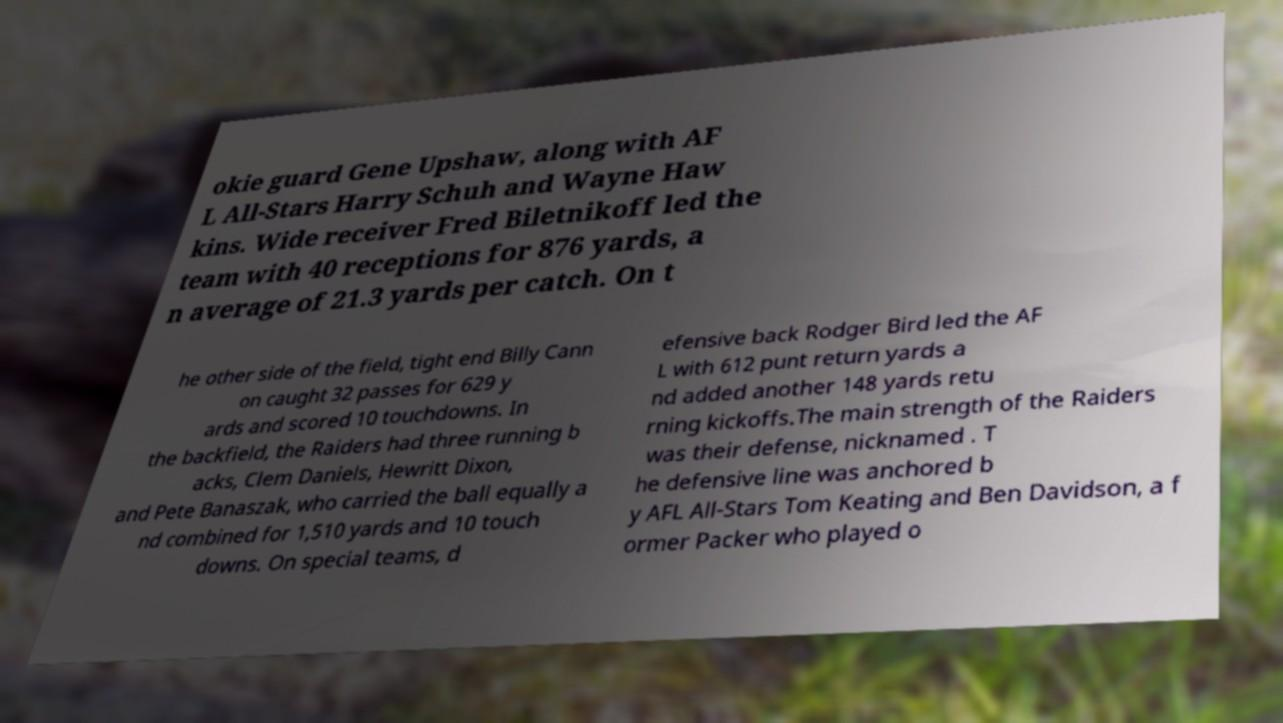I need the written content from this picture converted into text. Can you do that? okie guard Gene Upshaw, along with AF L All-Stars Harry Schuh and Wayne Haw kins. Wide receiver Fred Biletnikoff led the team with 40 receptions for 876 yards, a n average of 21.3 yards per catch. On t he other side of the field, tight end Billy Cann on caught 32 passes for 629 y ards and scored 10 touchdowns. In the backfield, the Raiders had three running b acks, Clem Daniels, Hewritt Dixon, and Pete Banaszak, who carried the ball equally a nd combined for 1,510 yards and 10 touch downs. On special teams, d efensive back Rodger Bird led the AF L with 612 punt return yards a nd added another 148 yards retu rning kickoffs.The main strength of the Raiders was their defense, nicknamed . T he defensive line was anchored b y AFL All-Stars Tom Keating and Ben Davidson, a f ormer Packer who played o 